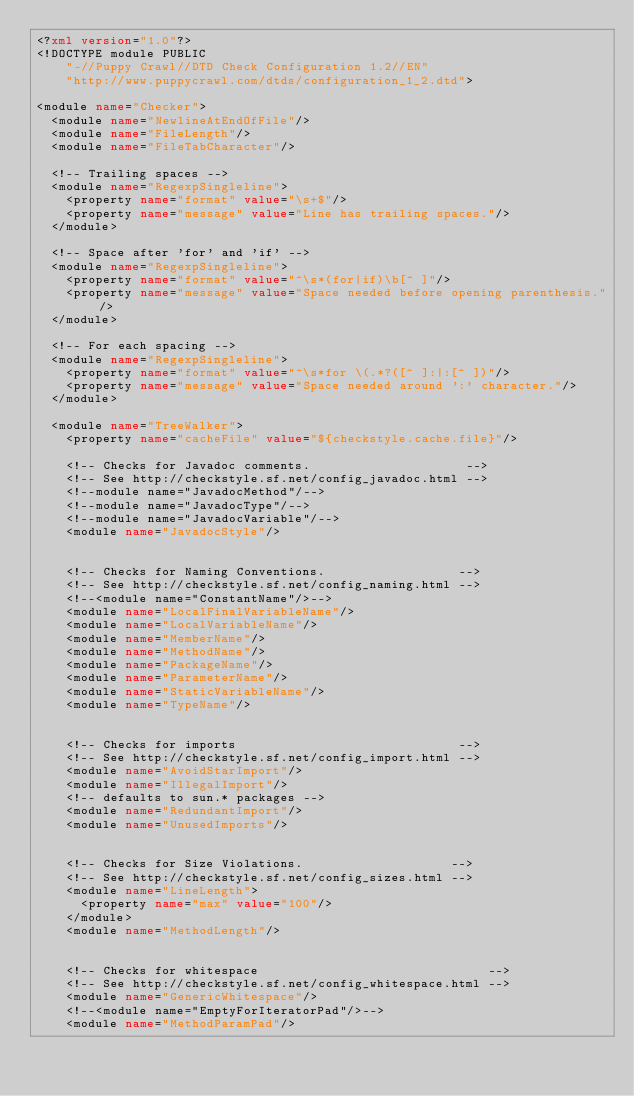Convert code to text. <code><loc_0><loc_0><loc_500><loc_500><_XML_><?xml version="1.0"?>
<!DOCTYPE module PUBLIC
    "-//Puppy Crawl//DTD Check Configuration 1.2//EN"
    "http://www.puppycrawl.com/dtds/configuration_1_2.dtd">

<module name="Checker">
  <module name="NewlineAtEndOfFile"/>
  <module name="FileLength"/>
  <module name="FileTabCharacter"/>

  <!-- Trailing spaces -->
  <module name="RegexpSingleline">
    <property name="format" value="\s+$"/>
    <property name="message" value="Line has trailing spaces."/>
  </module>

  <!-- Space after 'for' and 'if' -->
  <module name="RegexpSingleline">
    <property name="format" value="^\s*(for|if)\b[^ ]"/>
    <property name="message" value="Space needed before opening parenthesis."/>
  </module>

  <!-- For each spacing -->
  <module name="RegexpSingleline">
    <property name="format" value="^\s*for \(.*?([^ ]:|:[^ ])"/>
    <property name="message" value="Space needed around ':' character."/>
  </module>

  <module name="TreeWalker">
    <property name="cacheFile" value="${checkstyle.cache.file}"/>

    <!-- Checks for Javadoc comments.                     -->
    <!-- See http://checkstyle.sf.net/config_javadoc.html -->
    <!--module name="JavadocMethod"/-->
    <!--module name="JavadocType"/-->
    <!--module name="JavadocVariable"/-->
    <module name="JavadocStyle"/>


    <!-- Checks for Naming Conventions.                  -->
    <!-- See http://checkstyle.sf.net/config_naming.html -->
    <!--<module name="ConstantName"/>-->
    <module name="LocalFinalVariableName"/>
    <module name="LocalVariableName"/>
    <module name="MemberName"/>
    <module name="MethodName"/>
    <module name="PackageName"/>
    <module name="ParameterName"/>
    <module name="StaticVariableName"/>
    <module name="TypeName"/>


    <!-- Checks for imports                              -->
    <!-- See http://checkstyle.sf.net/config_import.html -->
    <module name="AvoidStarImport"/>
    <module name="IllegalImport"/>
    <!-- defaults to sun.* packages -->
    <module name="RedundantImport"/>
    <module name="UnusedImports"/>


    <!-- Checks for Size Violations.                    -->
    <!-- See http://checkstyle.sf.net/config_sizes.html -->
    <module name="LineLength">
      <property name="max" value="100"/>
    </module>
    <module name="MethodLength"/>


    <!-- Checks for whitespace                               -->
    <!-- See http://checkstyle.sf.net/config_whitespace.html -->
    <module name="GenericWhitespace"/>
    <!--<module name="EmptyForIteratorPad"/>-->
    <module name="MethodParamPad"/></code> 